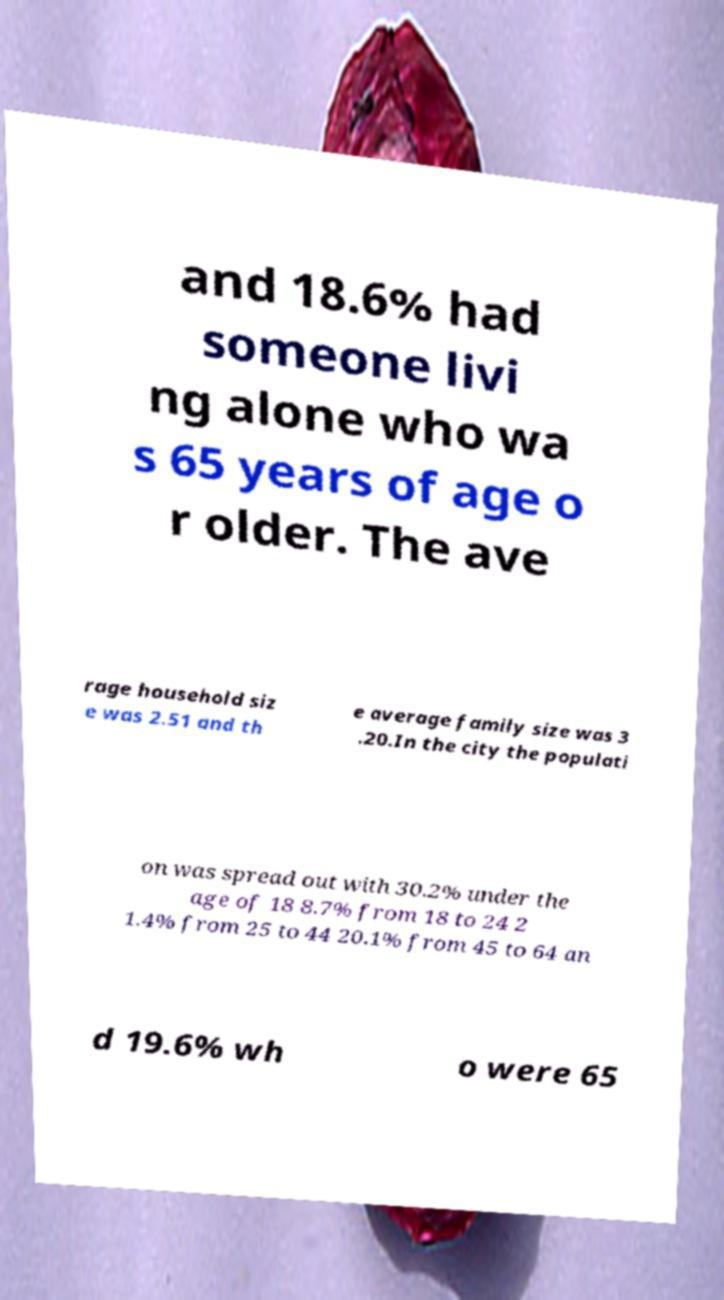Can you accurately transcribe the text from the provided image for me? and 18.6% had someone livi ng alone who wa s 65 years of age o r older. The ave rage household siz e was 2.51 and th e average family size was 3 .20.In the city the populati on was spread out with 30.2% under the age of 18 8.7% from 18 to 24 2 1.4% from 25 to 44 20.1% from 45 to 64 an d 19.6% wh o were 65 